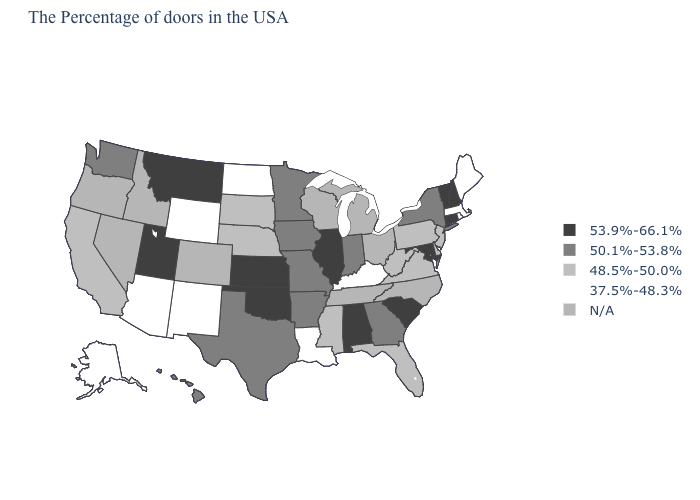Among the states that border New Jersey , which have the lowest value?
Keep it brief. Delaware, Pennsylvania. Which states have the lowest value in the USA?
Keep it brief. Maine, Massachusetts, Rhode Island, Kentucky, Louisiana, North Dakota, Wyoming, New Mexico, Arizona, Alaska. What is the value of North Carolina?
Short answer required. N/A. Does the first symbol in the legend represent the smallest category?
Be succinct. No. Which states have the lowest value in the USA?
Quick response, please. Maine, Massachusetts, Rhode Island, Kentucky, Louisiana, North Dakota, Wyoming, New Mexico, Arizona, Alaska. What is the value of Tennessee?
Short answer required. N/A. What is the lowest value in states that border Alabama?
Write a very short answer. 48.5%-50.0%. What is the value of Delaware?
Concise answer only. 48.5%-50.0%. Among the states that border Connecticut , which have the lowest value?
Be succinct. Massachusetts, Rhode Island. Name the states that have a value in the range 48.5%-50.0%?
Quick response, please. New Jersey, Delaware, Pennsylvania, Virginia, West Virginia, Florida, Mississippi, Nebraska, South Dakota, California. Among the states that border North Carolina , which have the highest value?
Be succinct. South Carolina. Name the states that have a value in the range 37.5%-48.3%?
Quick response, please. Maine, Massachusetts, Rhode Island, Kentucky, Louisiana, North Dakota, Wyoming, New Mexico, Arizona, Alaska. Name the states that have a value in the range 50.1%-53.8%?
Quick response, please. New York, Georgia, Indiana, Missouri, Arkansas, Minnesota, Iowa, Texas, Washington, Hawaii. Among the states that border Oregon , which have the lowest value?
Answer briefly. California. 